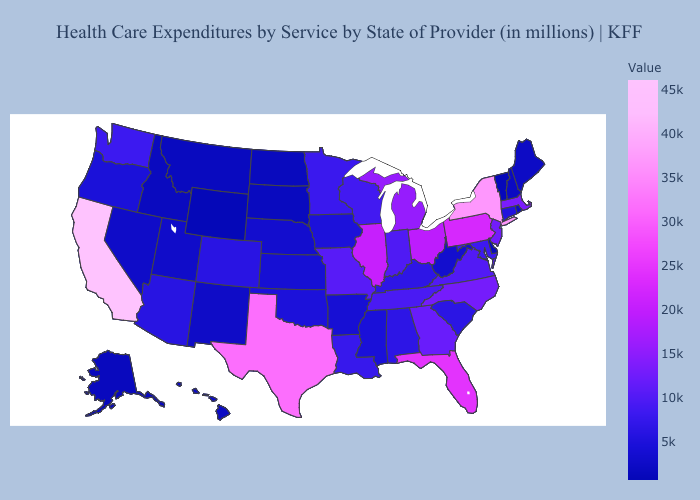Does Nebraska have a higher value than Ohio?
Short answer required. No. Does Wyoming have the lowest value in the USA?
Keep it brief. Yes. Which states have the lowest value in the South?
Short answer required. Delaware. Which states have the lowest value in the USA?
Concise answer only. Wyoming. Among the states that border West Virginia , which have the highest value?
Give a very brief answer. Pennsylvania. Does California have the highest value in the West?
Answer briefly. Yes. 